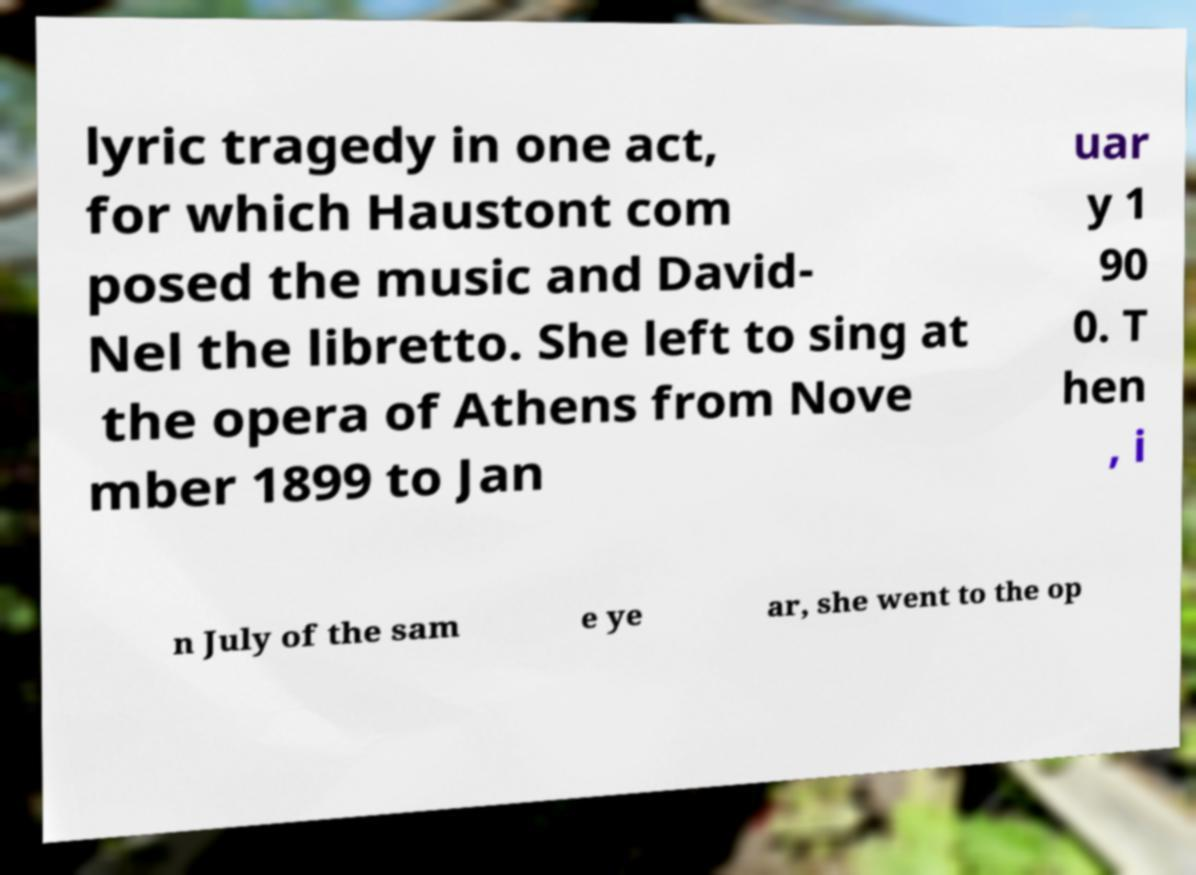There's text embedded in this image that I need extracted. Can you transcribe it verbatim? lyric tragedy in one act, for which Haustont com posed the music and David- Nel the libretto. She left to sing at the opera of Athens from Nove mber 1899 to Jan uar y 1 90 0. T hen , i n July of the sam e ye ar, she went to the op 